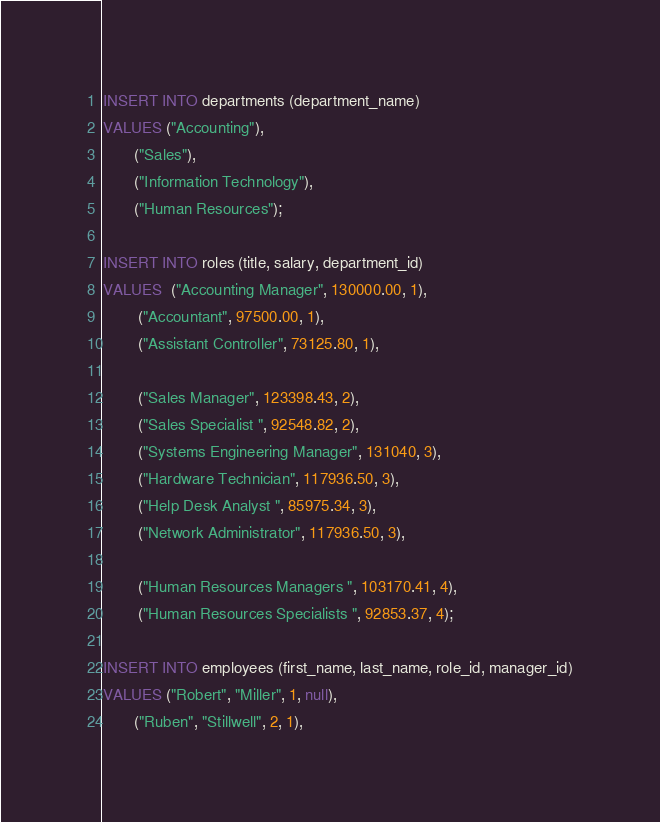Convert code to text. <code><loc_0><loc_0><loc_500><loc_500><_SQL_>INSERT INTO departments (department_name)
VALUES ("Accounting"),
       ("Sales"),
       ("Information Technology"),
       ("Human Resources");

INSERT INTO roles (title, salary, department_id)
VALUES  ("Accounting Manager", 130000.00, 1),
        ("Accountant", 97500.00, 1),
        ("Assistant Controller", 73125.80, 1),

        ("Sales Manager", 123398.43, 2),
        ("Sales Specialist ", 92548.82, 2),
        ("Systems Engineering Manager", 131040, 3),
        ("Hardware Technician", 117936.50, 3),
        ("Help Desk Analyst ", 85975.34, 3),
        ("Network Administrator", 117936.50, 3),

        ("Human Resources Managers ", 103170.41, 4),
        ("Human Resources Specialists ", 92853.37, 4);

INSERT INTO employees (first_name, last_name, role_id, manager_id)
VALUES ("Robert", "Miller", 1, null),
       ("Ruben", "Stillwell", 2, 1),</code> 